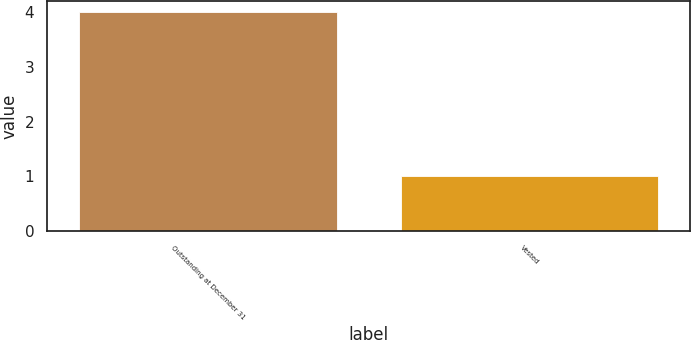Convert chart. <chart><loc_0><loc_0><loc_500><loc_500><bar_chart><fcel>Outstanding at December 31<fcel>Vested<nl><fcel>4<fcel>1<nl></chart> 